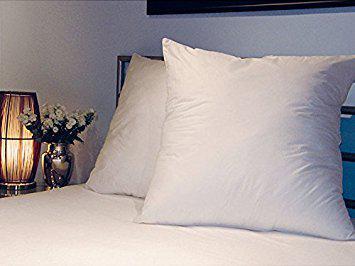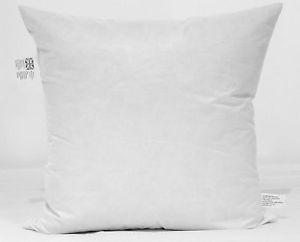The first image is the image on the left, the second image is the image on the right. For the images displayed, is the sentence "Two pillows are visible in the left image, while there is just one pillow on the right" factually correct? Answer yes or no. Yes. The first image is the image on the left, the second image is the image on the right. Analyze the images presented: Is the assertion "One image shows a single white rectangular pillow, and the other image shows a square upright pillow overlapping a pillow on its side." valid? Answer yes or no. No. 